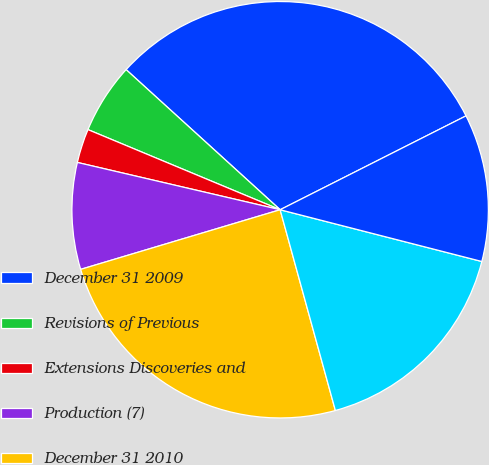<chart> <loc_0><loc_0><loc_500><loc_500><pie_chart><fcel>December 31 2009<fcel>Revisions of Previous<fcel>Extensions Discoveries and<fcel>Production (7)<fcel>December 31 2010<fcel>December 31 2011<fcel>December 31 2012<nl><fcel>30.81%<fcel>5.46%<fcel>2.64%<fcel>8.27%<fcel>24.65%<fcel>16.73%<fcel>11.44%<nl></chart> 